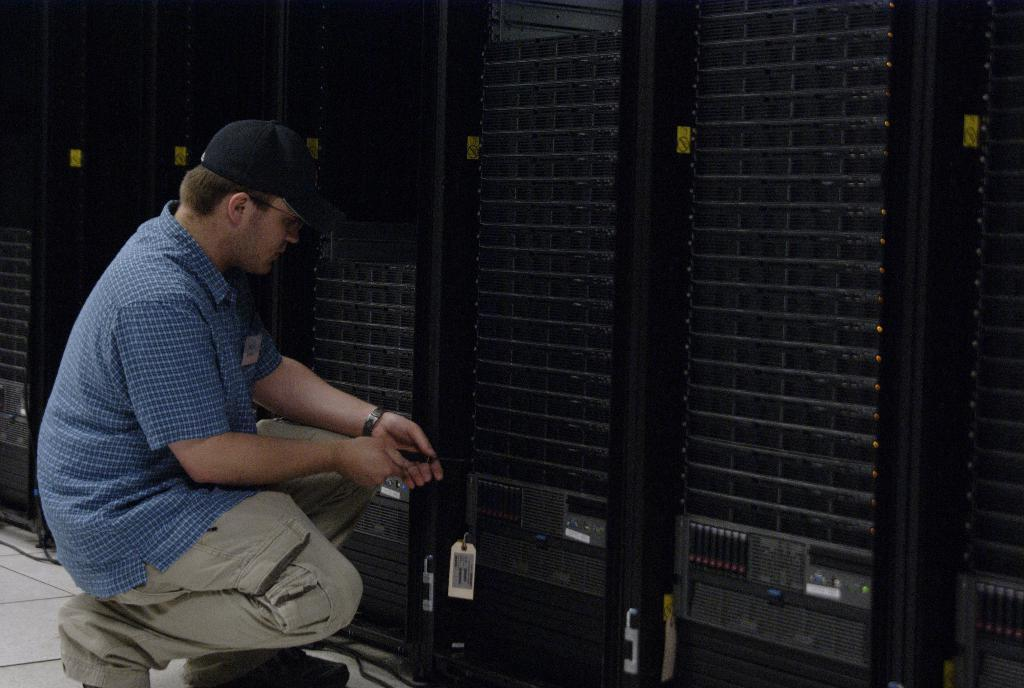Who is present in the image? There is a man in the image. What is the man doing in the image? The man is holding an object. What can be seen in the background of the image? There are machines in the background of the image. What type of clouds can be seen in the image? There are no clouds visible in the image; it features a man holding an object and machines in the background. 